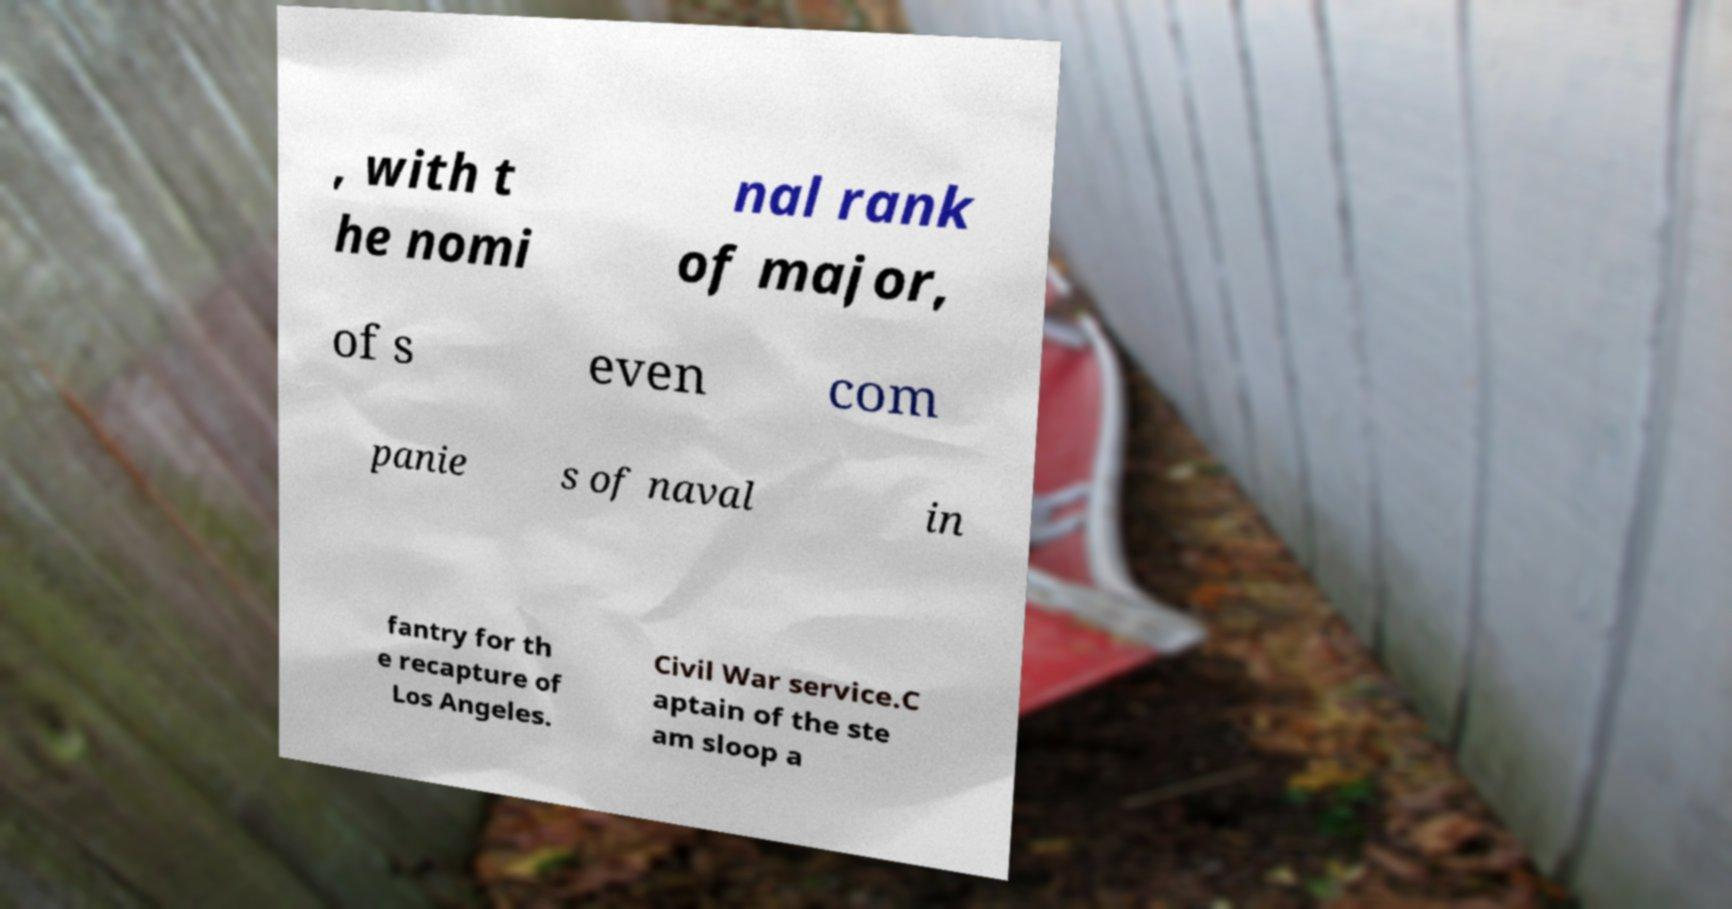Could you extract and type out the text from this image? , with t he nomi nal rank of major, of s even com panie s of naval in fantry for th e recapture of Los Angeles. Civil War service.C aptain of the ste am sloop a 